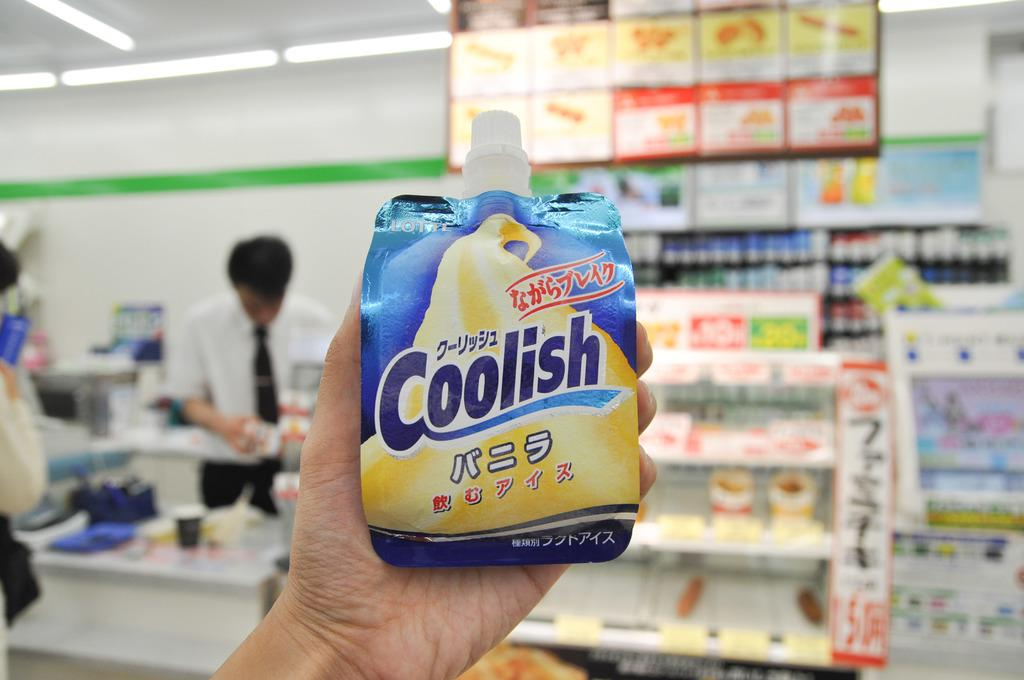Provide a one-sentence caption for the provided image. Someone holding up a packaged product called Coolish. 